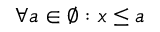Convert formula to latex. <formula><loc_0><loc_0><loc_500><loc_500>\forall a \in \varnothing \colon x \leq a</formula> 